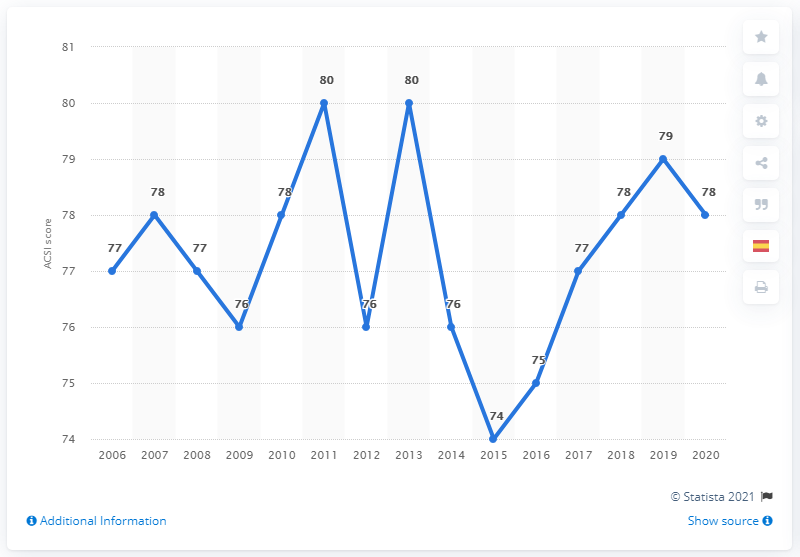What was Starbucks' ACSI score in 2020?
 78 